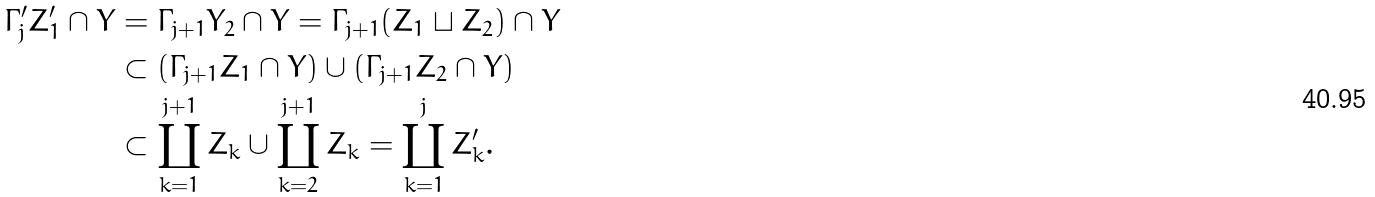<formula> <loc_0><loc_0><loc_500><loc_500>\Gamma ^ { \prime } _ { j } Z ^ { \prime } _ { 1 } \cap Y & = \Gamma _ { j + 1 } Y _ { 2 } \cap Y = \Gamma _ { j + 1 } ( Z _ { 1 } \sqcup Z _ { 2 } ) \cap Y \\ & \subset ( \Gamma _ { j + 1 } Z _ { 1 } \cap Y ) \cup ( \Gamma _ { j + 1 } Z _ { 2 } \cap Y ) \\ & \subset \coprod _ { k = 1 } ^ { j + 1 } Z _ { k } \cup \coprod _ { k = 2 } ^ { j + 1 } Z _ { k } = \coprod _ { k = 1 } ^ { j } Z ^ { \prime } _ { k } .</formula> 